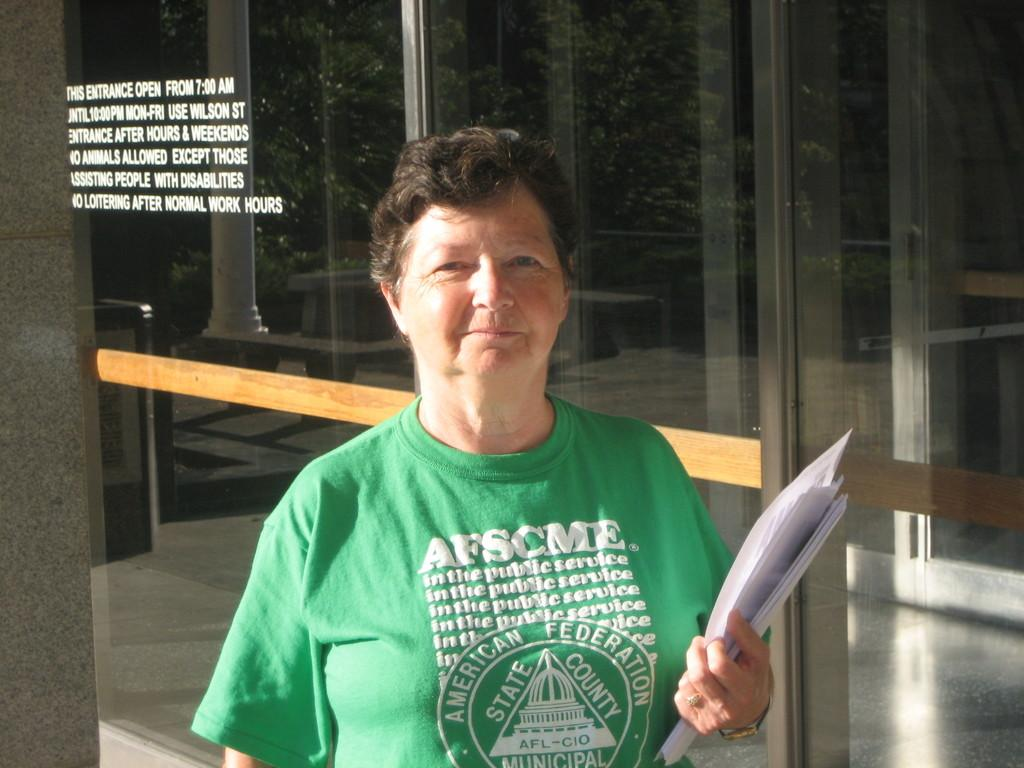Who is present in the image? There is a woman in the image. What is the woman holding? The woman is holding papers. What can be seen on a glass surface in the image? There is text on a glass surface in the image. What is visible in the mirror reflection? Trees are visible in the mirror reflection. What type of punishment is being administered to the woman in the image? There is no indication of punishment in the image; the woman is simply holding papers. 